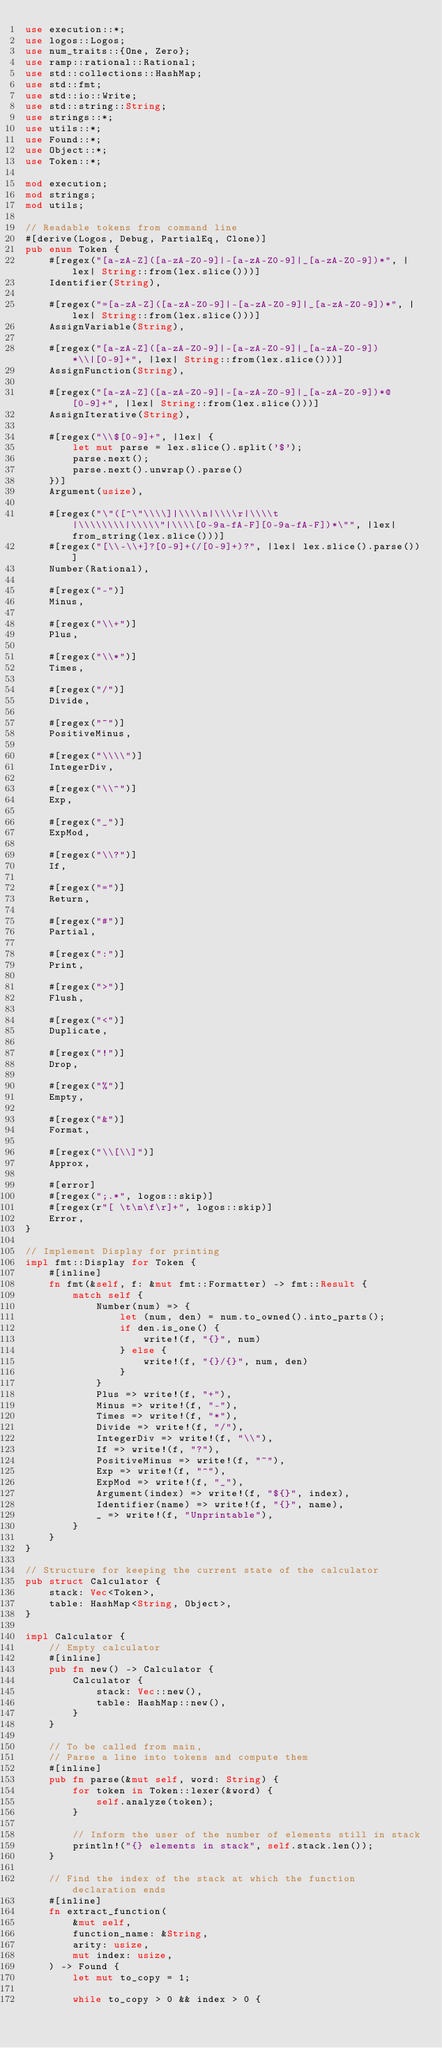<code> <loc_0><loc_0><loc_500><loc_500><_Rust_>use execution::*;
use logos::Logos;
use num_traits::{One, Zero};
use ramp::rational::Rational;
use std::collections::HashMap;
use std::fmt;
use std::io::Write;
use std::string::String;
use strings::*;
use utils::*;
use Found::*;
use Object::*;
use Token::*;

mod execution;
mod strings;
mod utils;

// Readable tokens from command line
#[derive(Logos, Debug, PartialEq, Clone)]
pub enum Token {
    #[regex("[a-zA-Z]([a-zA-Z0-9]|-[a-zA-Z0-9]|_[a-zA-Z0-9])*", |lex| String::from(lex.slice()))]
    Identifier(String),

    #[regex("=[a-zA-Z]([a-zA-Z0-9]|-[a-zA-Z0-9]|_[a-zA-Z0-9])*", |lex| String::from(lex.slice()))]
    AssignVariable(String),

    #[regex("[a-zA-Z]([a-zA-Z0-9]|-[a-zA-Z0-9]|_[a-zA-Z0-9])*\\|[0-9]+", |lex| String::from(lex.slice()))]
    AssignFunction(String),

    #[regex("[a-zA-Z]([a-zA-Z0-9]|-[a-zA-Z0-9]|_[a-zA-Z0-9])*@[0-9]+", |lex| String::from(lex.slice()))]
    AssignIterative(String),

    #[regex("\\$[0-9]+", |lex| {
        let mut parse = lex.slice().split('$');
        parse.next();
        parse.next().unwrap().parse()
    })]
    Argument(usize),

    #[regex("\"([^\"\\\\]|\\\\n|\\\\r|\\\\t|\\\\\\\\|\\\\\"|\\\\[0-9a-fA-F][0-9a-fA-F])*\"", |lex| from_string(lex.slice()))]
    #[regex("[\\-\\+]?[0-9]+(/[0-9]+)?", |lex| lex.slice().parse())]
    Number(Rational),

    #[regex("-")]
    Minus,

    #[regex("\\+")]
    Plus,

    #[regex("\\*")]
    Times,

    #[regex("/")]
    Divide,

    #[regex("~")]
    PositiveMinus,

    #[regex("\\\\")]
    IntegerDiv,

    #[regex("\\^")]
    Exp,

    #[regex("_")]
    ExpMod,

    #[regex("\\?")]
    If,

    #[regex("=")]
    Return,

    #[regex("#")]
    Partial,

    #[regex(":")]
    Print,

    #[regex(">")]
    Flush,

    #[regex("<")]
    Duplicate,

    #[regex("!")]
    Drop,

    #[regex("%")]
    Empty,

    #[regex("&")]
    Format,

    #[regex("\\[\\]")]
    Approx,

    #[error]
    #[regex(";.*", logos::skip)]
    #[regex(r"[ \t\n\f\r]+", logos::skip)]
    Error,
}

// Implement Display for printing
impl fmt::Display for Token {
    #[inline]
    fn fmt(&self, f: &mut fmt::Formatter) -> fmt::Result {
        match self {
            Number(num) => {
                let (num, den) = num.to_owned().into_parts();
                if den.is_one() {
                    write!(f, "{}", num)
                } else {
                    write!(f, "{}/{}", num, den)
                }
            }
            Plus => write!(f, "+"),
            Minus => write!(f, "-"),
            Times => write!(f, "*"),
            Divide => write!(f, "/"),
            IntegerDiv => write!(f, "\\"),
            If => write!(f, "?"),
            PositiveMinus => write!(f, "~"),
            Exp => write!(f, "^"),
            ExpMod => write!(f, "_"),
            Argument(index) => write!(f, "${}", index),
            Identifier(name) => write!(f, "{}", name),
            _ => write!(f, "Unprintable"),
        }
    }
}

// Structure for keeping the current state of the calculator
pub struct Calculator {
    stack: Vec<Token>,
    table: HashMap<String, Object>,
}

impl Calculator {
    // Empty calculator
    #[inline]
    pub fn new() -> Calculator {
        Calculator {
            stack: Vec::new(),
            table: HashMap::new(),
        }
    }

    // To be called from main,
    // Parse a line into tokens and compute them
    #[inline]
    pub fn parse(&mut self, word: String) {
        for token in Token::lexer(&word) {
            self.analyze(token);
        }

        // Inform the user of the number of elements still in stack
        println!("{} elements in stack", self.stack.len());
    }

    // Find the index of the stack at which the function declaration ends
    #[inline]
    fn extract_function(
        &mut self,
        function_name: &String,
        arity: usize,
        mut index: usize,
    ) -> Found {
        let mut to_copy = 1;

        while to_copy > 0 && index > 0 {</code> 